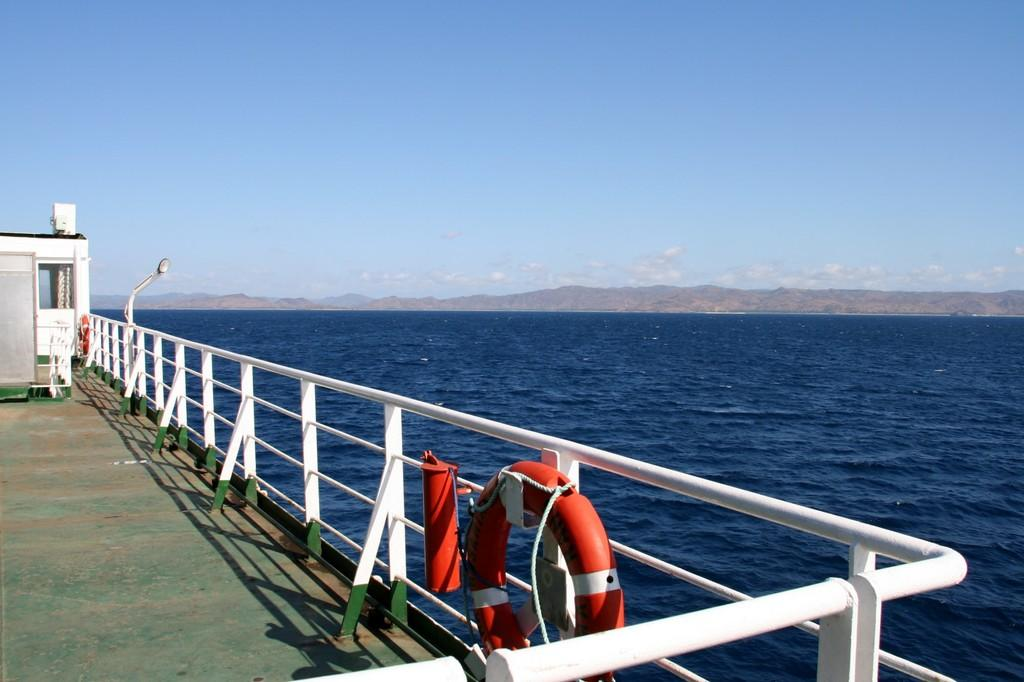What is the main structure in the image? There is a platform in the image. What is located beside the platform? There is a fence beside the platform. What type of recreational item can be seen in the image? There is a swim tube in the image. What else is visible in the image besides the platform, fence, and swim tube? There are other objects visible in the image. What can be seen in the background of the image? There is water, mountains, and the sky visible in the background of the image. What grade did the ladybug receive on its recent math test in the image? There is no ladybug present in the image, and therefore no information about its math test or grade. 